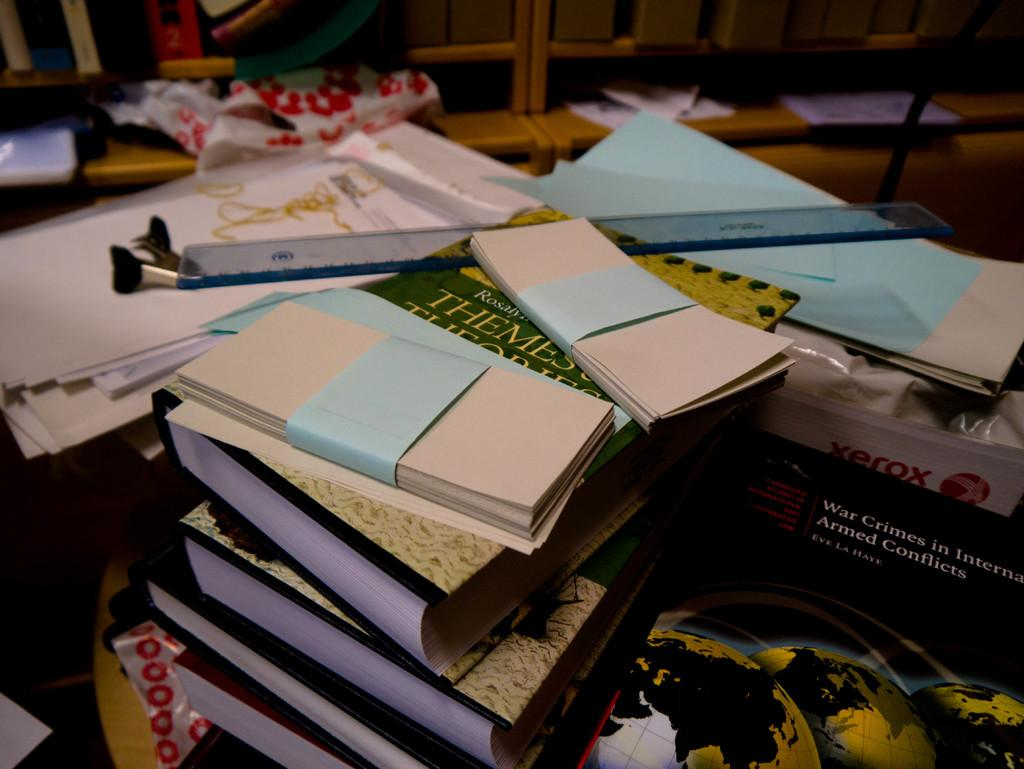<image>
Create a compact narrative representing the image presented. "War Crimes In International Armed Conflicts" is one of the many books lying on the table. 